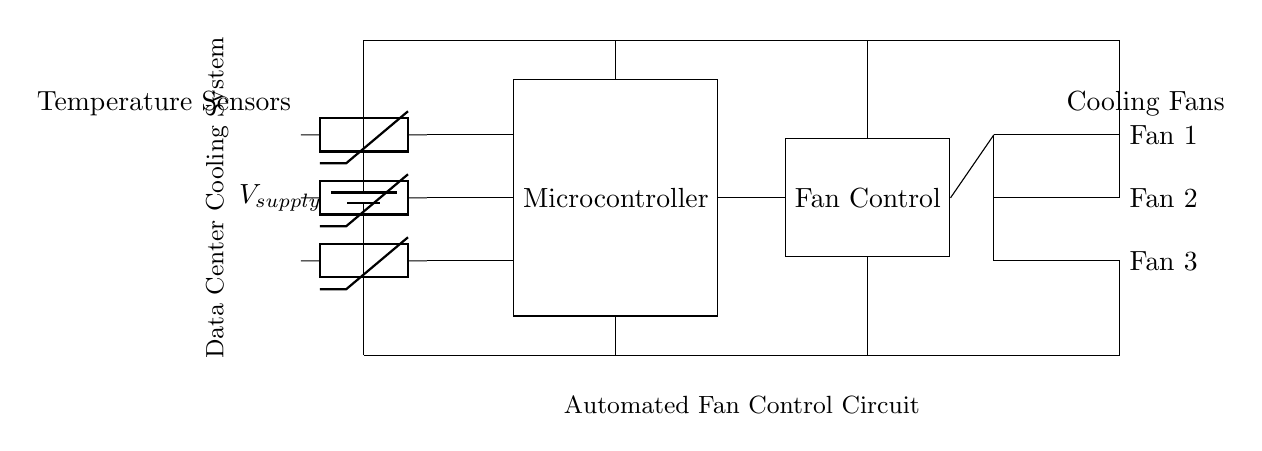What is the main power supply voltage in this circuit? The circuit shows a supply voltage labeled as V_supply, and typically this would represent a specific voltage value; in this case, it simply indicates that the supply voltage is present without a specific numerical value given.
Answer: V_supply How many temperature sensors are there? The diagram clearly shows three thermistors connected to the microcontroller, indicating the number of temperature sensors in the cooling circuit.
Answer: Three What is the role of the microcontroller in this circuit? The microcontroller acts as the central processing unit that receives data from the temperature sensors, processes that data, and controls the fan operation based on the temperature readings.
Answer: Control Which components are considered cooling fans? The diagram identifies three cooling fans, labeled as Fan 1, Fan 2, and Fan 3, that are connected to the fan control system for automated operation.
Answer: Fan 1, Fan 2, Fan 3 How are the cooling fans powered? The circuit shows that the cooling fans are connected to both the power supply through the fan control and grounded, allowing them to operate and be controlled by the microcontroller.
Answer: Through fan control What is the purpose of the fan control in this circuit? The fan control component is designed to manage the activation of the cooling fans based on signals from the microcontroller, ensuring that the cooling system responds appropriately to temperature changes.
Answer: Manage fans Where does the data from the temperature sensors go? The data from the temperature sensors is directed to the microcontroller for processing, indicating that the sensors are integral in providing real-time temperature readings for cooling management.
Answer: Microcontroller 